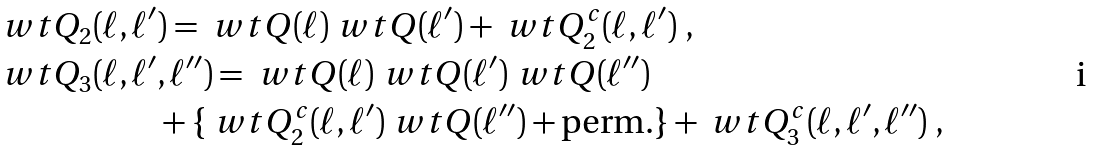<formula> <loc_0><loc_0><loc_500><loc_500>\ w t Q _ { 2 } ( \ell , \ell ^ { \prime } & ) = \ w t Q ( \ell ) \ w t Q ( \ell ^ { \prime } ) + \ w t Q _ { 2 } ^ { c } ( \ell , \ell ^ { \prime } ) \ , \\ \ w t Q _ { 3 } ( \ell , \ell ^ { \prime } & , \ell ^ { \prime \prime } ) = \ w t Q ( \ell ) \ w t Q ( \ell ^ { \prime } ) \ w t Q ( \ell ^ { \prime \prime } ) \\ & + \{ \ w t Q _ { 2 } ^ { c } ( \ell , \ell ^ { \prime } ) \ w t Q ( \ell ^ { \prime \prime } ) + \text {perm.} \} + \ w t Q _ { 3 } ^ { c } ( \ell , \ell ^ { \prime } , \ell ^ { \prime \prime } ) \ , \\</formula> 